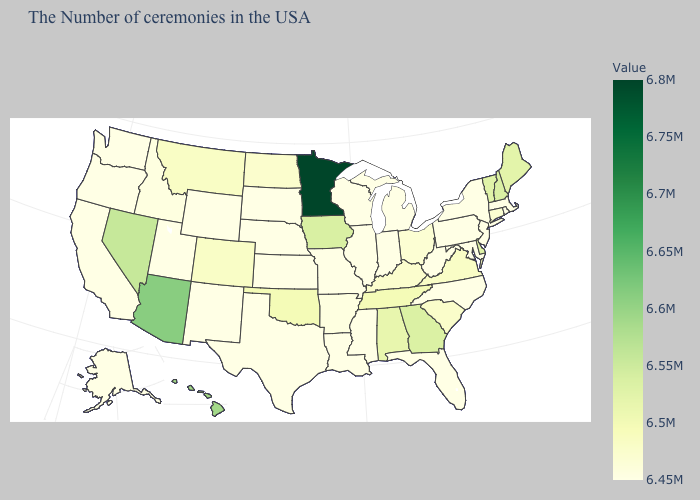Which states have the highest value in the USA?
Short answer required. Minnesota. Is the legend a continuous bar?
Be succinct. Yes. Is the legend a continuous bar?
Answer briefly. Yes. Among the states that border New Hampshire , does Massachusetts have the highest value?
Keep it brief. No. Which states have the lowest value in the West?
Answer briefly. Wyoming, New Mexico, Utah, California, Washington, Oregon, Alaska. Among the states that border Louisiana , which have the lowest value?
Keep it brief. Mississippi, Texas. Does the map have missing data?
Give a very brief answer. No. 